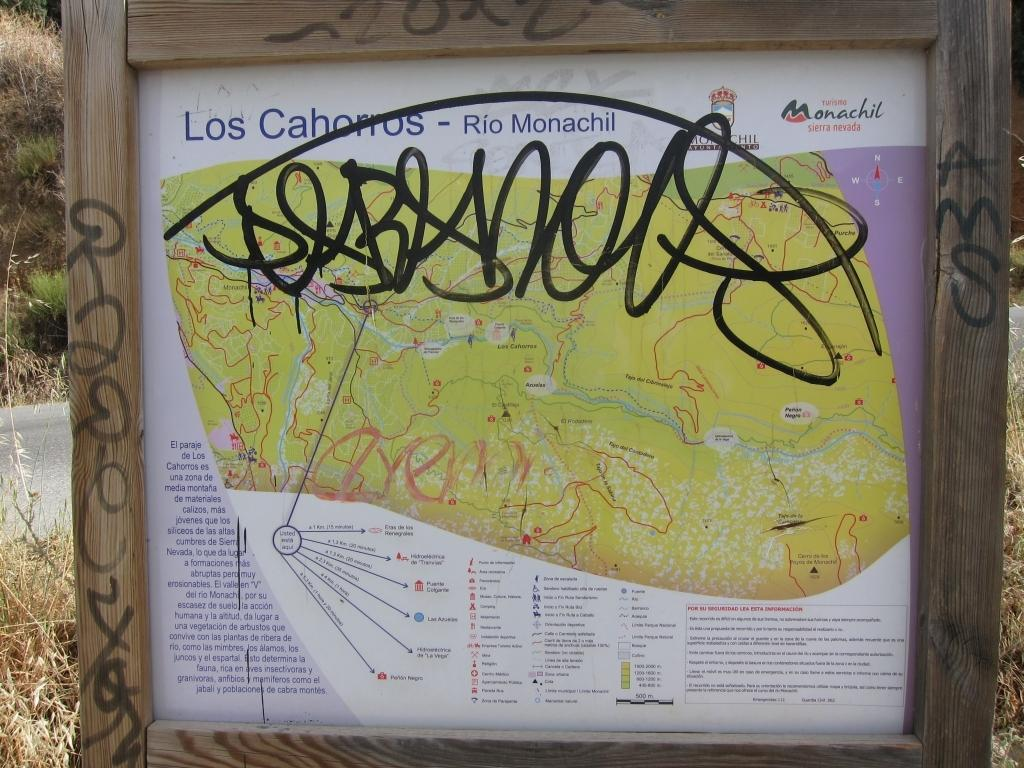<image>
Offer a succinct explanation of the picture presented. A sign showing points of interest at Los Cahorros, Rio Monachil 